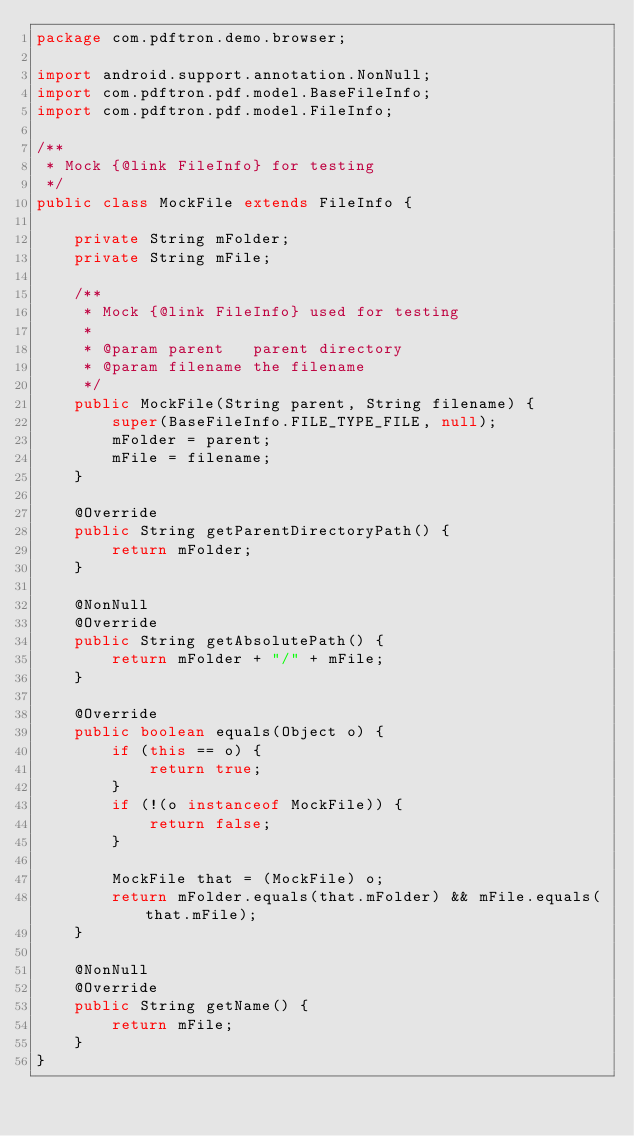<code> <loc_0><loc_0><loc_500><loc_500><_Java_>package com.pdftron.demo.browser;

import android.support.annotation.NonNull;
import com.pdftron.pdf.model.BaseFileInfo;
import com.pdftron.pdf.model.FileInfo;

/**
 * Mock {@link FileInfo} for testing
 */
public class MockFile extends FileInfo {

    private String mFolder;
    private String mFile;

    /**
     * Mock {@link FileInfo} used for testing
     *
     * @param parent   parent directory
     * @param filename the filename
     */
    public MockFile(String parent, String filename) {
        super(BaseFileInfo.FILE_TYPE_FILE, null);
        mFolder = parent;
        mFile = filename;
    }

    @Override
    public String getParentDirectoryPath() {
        return mFolder;
    }

    @NonNull
    @Override
    public String getAbsolutePath() {
        return mFolder + "/" + mFile;
    }

    @Override
    public boolean equals(Object o) {
        if (this == o) {
            return true;
        }
        if (!(o instanceof MockFile)) {
            return false;
        }

        MockFile that = (MockFile) o;
        return mFolder.equals(that.mFolder) && mFile.equals(that.mFile);
    }

    @NonNull
    @Override
    public String getName() {
        return mFile;
    }
}</code> 